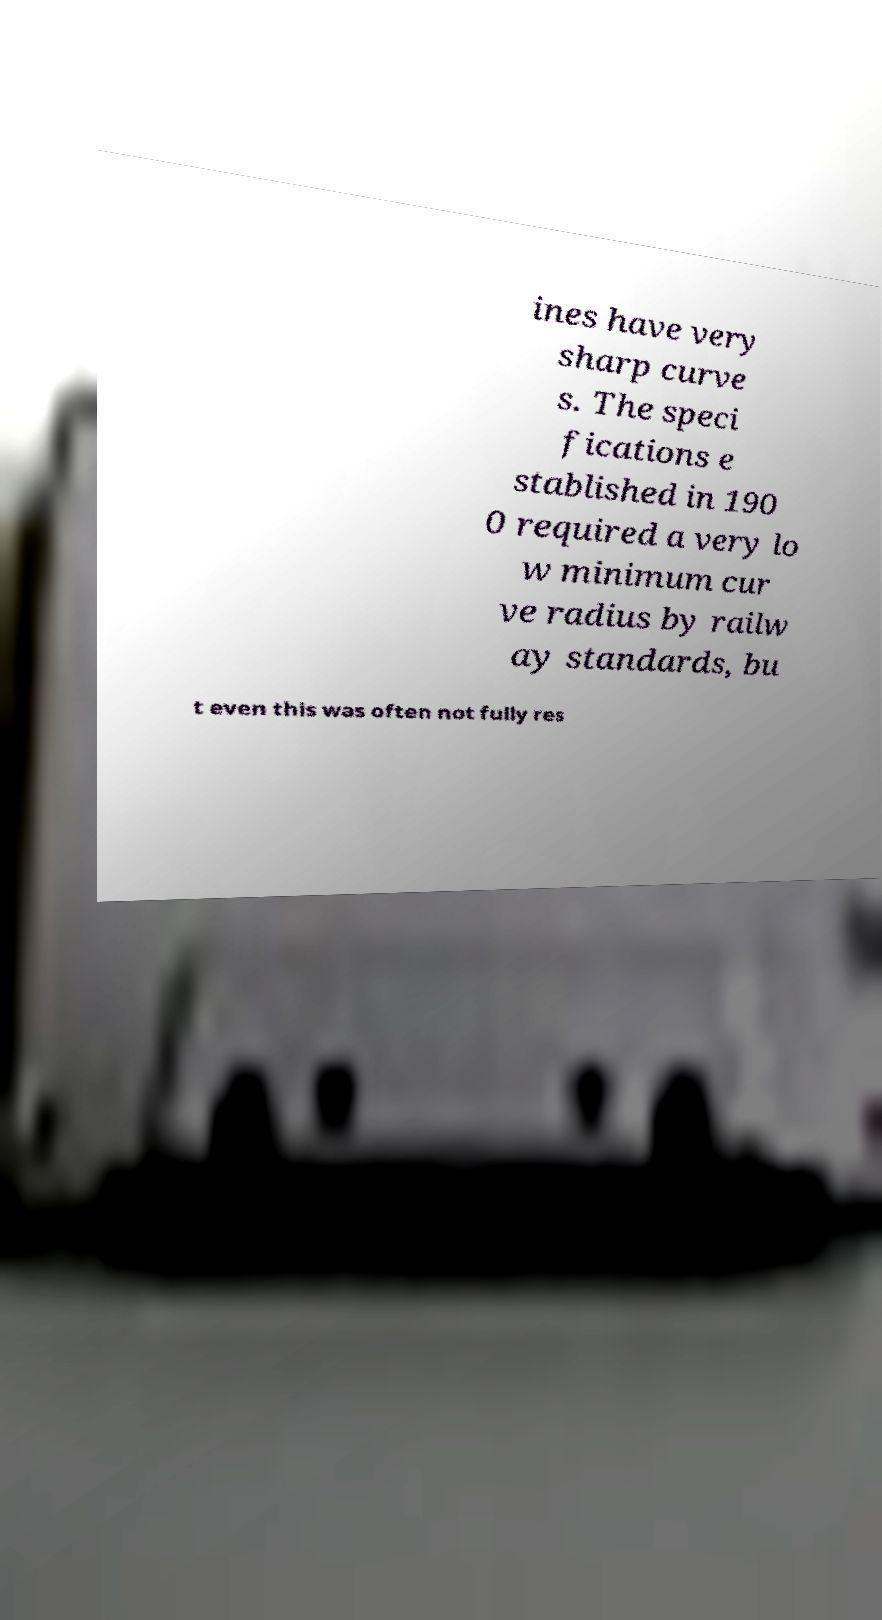Could you extract and type out the text from this image? ines have very sharp curve s. The speci fications e stablished in 190 0 required a very lo w minimum cur ve radius by railw ay standards, bu t even this was often not fully res 